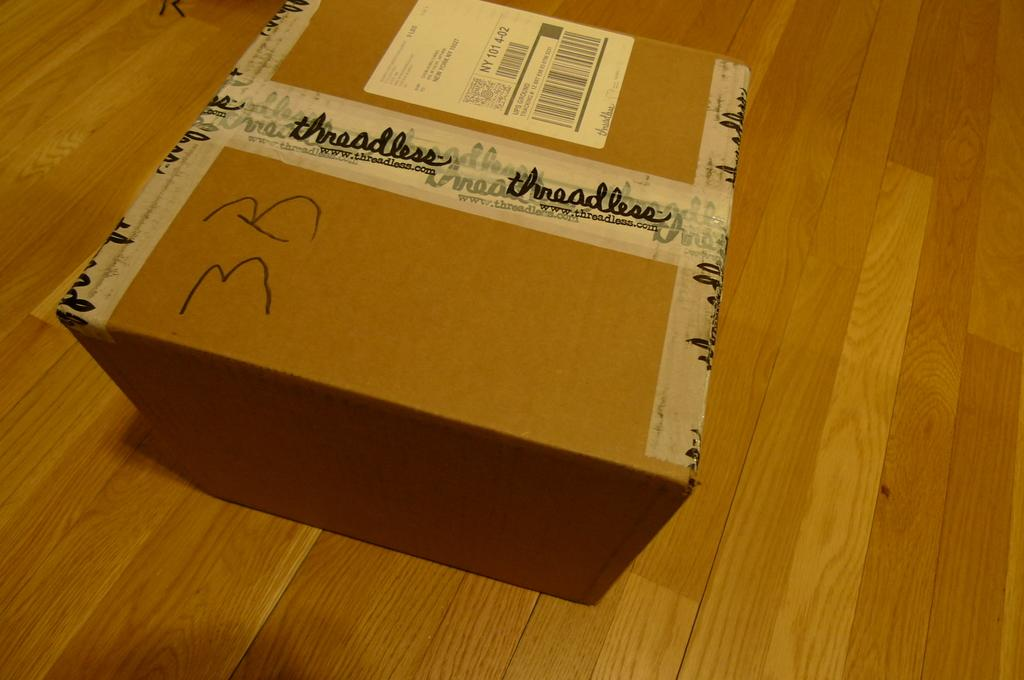Provide a one-sentence caption for the provided image. A package has been delivered from a company called Threadless. 